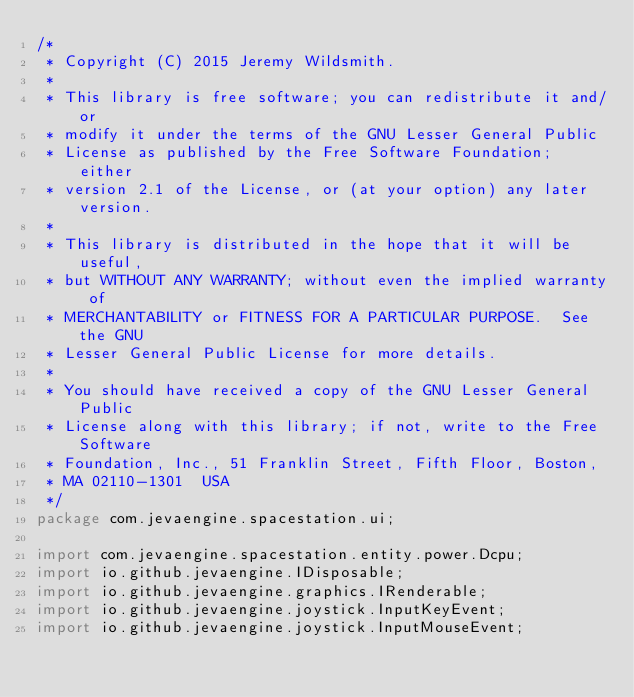Convert code to text. <code><loc_0><loc_0><loc_500><loc_500><_Java_>/* 
 * Copyright (C) 2015 Jeremy Wildsmith.
 *
 * This library is free software; you can redistribute it and/or
 * modify it under the terms of the GNU Lesser General Public
 * License as published by the Free Software Foundation; either
 * version 2.1 of the License, or (at your option) any later version.
 *
 * This library is distributed in the hope that it will be useful,
 * but WITHOUT ANY WARRANTY; without even the implied warranty of
 * MERCHANTABILITY or FITNESS FOR A PARTICULAR PURPOSE.  See the GNU
 * Lesser General Public License for more details.
 *
 * You should have received a copy of the GNU Lesser General Public
 * License along with this library; if not, write to the Free Software
 * Foundation, Inc., 51 Franklin Street, Fifth Floor, Boston,
 * MA 02110-1301  USA
 */
package com.jevaengine.spacestation.ui;

import com.jevaengine.spacestation.entity.power.Dcpu;
import io.github.jevaengine.IDisposable;
import io.github.jevaengine.graphics.IRenderable;
import io.github.jevaengine.joystick.InputKeyEvent;
import io.github.jevaengine.joystick.InputMouseEvent;</code> 